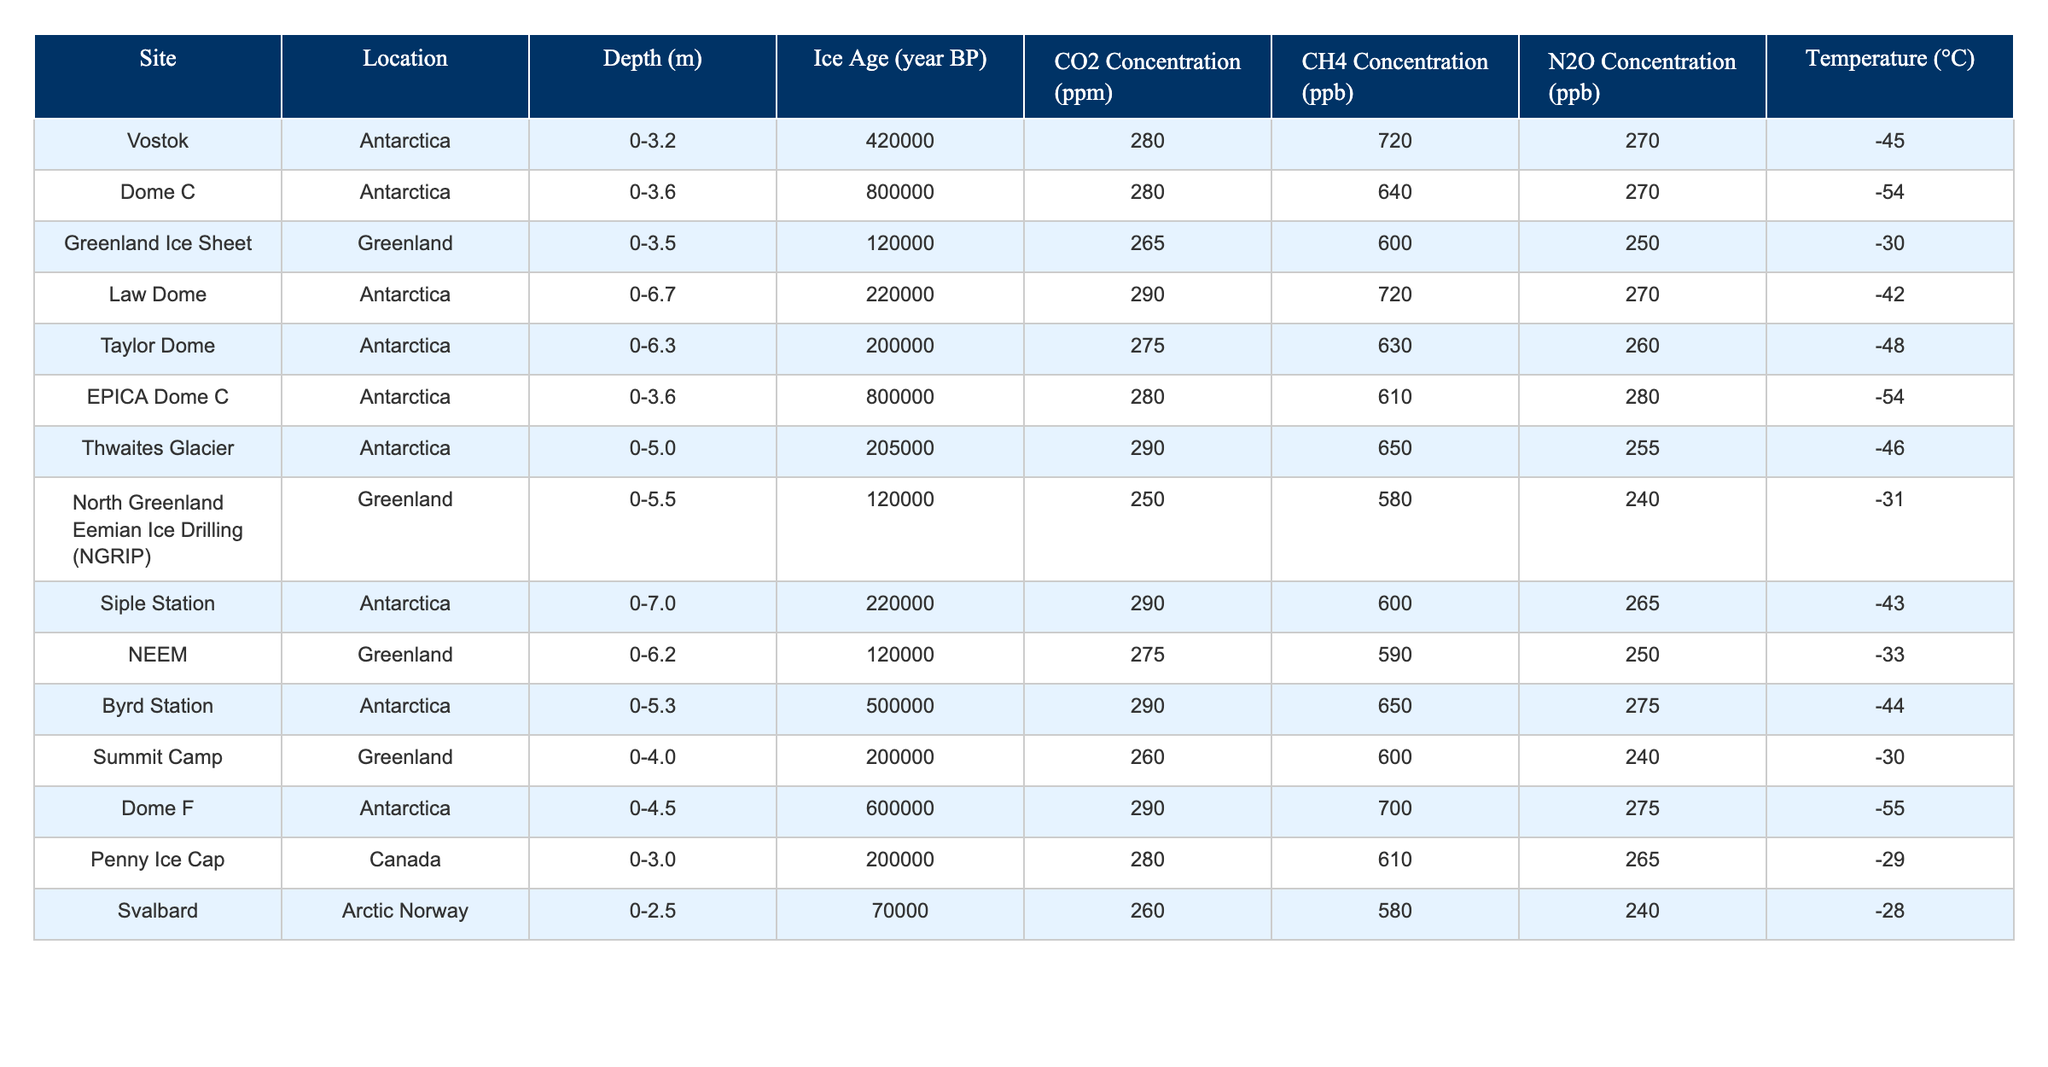What is the CO2 concentration at the Vostok site? The table shows that the CO2 concentration for the Vostok site in Antarctica is 280 ppm.
Answer: 280 ppm Which site has the highest CH4 concentration? By evaluating the CH4 concentrations across all sites, Law Dome and Byrd Station both have the highest value of 720 ppb.
Answer: Law Dome and Byrd Station What is the average N2O concentration of the Antarctic sites listed? The Antarctic sites listed are Vostok, Dome C, Law Dome, Taylor Dome, Byrd Station, Siple Station, and Dome F. Their N2O concentrations are 270, 270, 270, 260, 275, 265, and 275 ppb respectively. The average is calculated as (270 + 270 + 270 + 260 + 275 + 265 + 275) / 7 = 270
Answer: 270 ppb Is the temperature at the North Greenland Eemian Ice Drilling site higher than that at the Greenland Ice Sheet site? The temperature at the North Greenland Eemian Ice Drilling site is -31 °C, while the Greenland Ice Sheet has a temperature of -30 °C. Therefore, -30 °C is not less than -31 °C; it is indeed higher.
Answer: Yes Which site from the table has the oldest ice age? The table indicates that Dome C has an ice age of 800,000 years BP, which is the oldest among all sites listed.
Answer: Dome C What is the difference in CO2 concentration between the Thwaites Glacier and the Greenland Ice Sheet? The CO2 concentration at Thwaites Glacier is 290 ppm and at the Greenland Ice Sheet is 265 ppm. The difference is calculated as 290 - 265 = 25 ppm.
Answer: 25 ppm How many sites have a CO2 concentration greater than 275 ppm? Evaluating the CO2 concentrations, the sites in the table with greater than 275 ppm are Law Dome, Thwaites Glacier, Byrd Station, and Dome F. There are a total of 4 sites.
Answer: 4 What is the temperature range observed at the Arctic Norway site? The table shows only one temperature value for the Svalbard site in Arctic Norway, which is -28 °C. There is no range since it is a single data point.
Answer: No range available If we consider only the Antarctic sites, what is the average depth of the ice cores? The depths of the Antarctic sites are 3.2 m (Vostok), 3.6 m (Dome C), 6.7 m (Law Dome), 6.3 m (Taylor Dome), 7.0 m (Siple Station), and 4.5 m (Dome F). The average is calculated as (3.2 + 3.6 + 6.7 + 6.3 + 7.0 + 4.5) / 6 = 5.2 m.
Answer: 5.2 m Which gas concentration shows a consistent value of 270 ppb across multiple Antarctic sites? The N2O concentration is consistently recorded at 270 ppb for Vostok and Dome C, meeting this criterion.
Answer: N2O concentration Was the temperature at the Dome F site higher than that at the Taylor Dome site? The temperature at Dome F is -55 °C and at Taylor Dome is -48 °C. Since -48 °C is higher than -55 °C, Dome F was colder.
Answer: No, Dome F is colder 